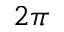<formula> <loc_0><loc_0><loc_500><loc_500>2 \pi</formula> 